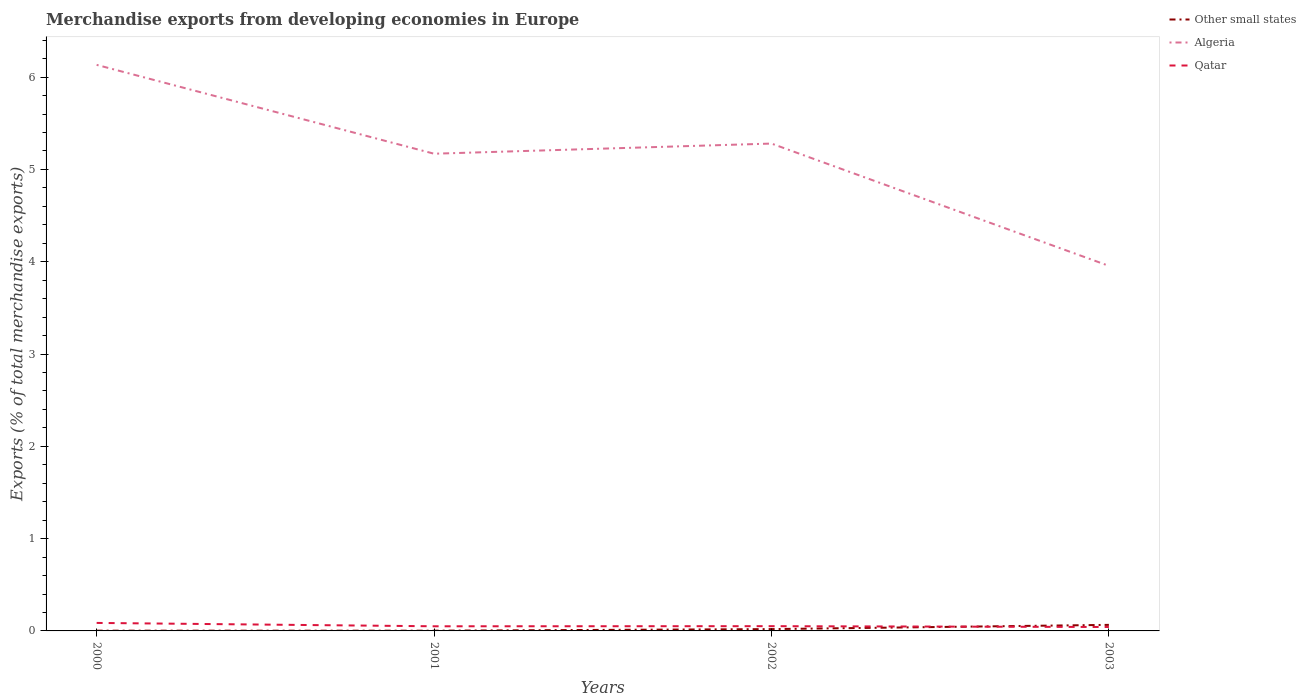Across all years, what is the maximum percentage of total merchandise exports in Algeria?
Offer a very short reply. 3.96. In which year was the percentage of total merchandise exports in Qatar maximum?
Offer a terse response. 2003. What is the total percentage of total merchandise exports in Algeria in the graph?
Give a very brief answer. 0.85. What is the difference between the highest and the second highest percentage of total merchandise exports in Other small states?
Provide a short and direct response. 0.06. What is the difference between the highest and the lowest percentage of total merchandise exports in Other small states?
Your answer should be very brief. 1. How many lines are there?
Offer a terse response. 3. Are the values on the major ticks of Y-axis written in scientific E-notation?
Provide a short and direct response. No. Where does the legend appear in the graph?
Your answer should be very brief. Top right. How many legend labels are there?
Make the answer very short. 3. How are the legend labels stacked?
Offer a terse response. Vertical. What is the title of the graph?
Keep it short and to the point. Merchandise exports from developing economies in Europe. Does "Korea (Republic)" appear as one of the legend labels in the graph?
Make the answer very short. No. What is the label or title of the Y-axis?
Make the answer very short. Exports (% of total merchandise exports). What is the Exports (% of total merchandise exports) in Other small states in 2000?
Your answer should be very brief. 0. What is the Exports (% of total merchandise exports) in Algeria in 2000?
Offer a terse response. 6.13. What is the Exports (% of total merchandise exports) in Qatar in 2000?
Make the answer very short. 0.09. What is the Exports (% of total merchandise exports) in Other small states in 2001?
Give a very brief answer. 0. What is the Exports (% of total merchandise exports) in Algeria in 2001?
Make the answer very short. 5.17. What is the Exports (% of total merchandise exports) in Qatar in 2001?
Your response must be concise. 0.05. What is the Exports (% of total merchandise exports) in Other small states in 2002?
Offer a terse response. 0.02. What is the Exports (% of total merchandise exports) of Algeria in 2002?
Offer a very short reply. 5.28. What is the Exports (% of total merchandise exports) of Qatar in 2002?
Your response must be concise. 0.05. What is the Exports (% of total merchandise exports) in Other small states in 2003?
Your answer should be very brief. 0.07. What is the Exports (% of total merchandise exports) in Algeria in 2003?
Keep it short and to the point. 3.96. What is the Exports (% of total merchandise exports) of Qatar in 2003?
Make the answer very short. 0.04. Across all years, what is the maximum Exports (% of total merchandise exports) of Other small states?
Give a very brief answer. 0.07. Across all years, what is the maximum Exports (% of total merchandise exports) in Algeria?
Provide a short and direct response. 6.13. Across all years, what is the maximum Exports (% of total merchandise exports) of Qatar?
Offer a terse response. 0.09. Across all years, what is the minimum Exports (% of total merchandise exports) of Other small states?
Your answer should be compact. 0. Across all years, what is the minimum Exports (% of total merchandise exports) of Algeria?
Offer a terse response. 3.96. Across all years, what is the minimum Exports (% of total merchandise exports) in Qatar?
Offer a very short reply. 0.04. What is the total Exports (% of total merchandise exports) of Other small states in the graph?
Provide a succinct answer. 0.09. What is the total Exports (% of total merchandise exports) in Algeria in the graph?
Offer a terse response. 20.54. What is the total Exports (% of total merchandise exports) in Qatar in the graph?
Your answer should be compact. 0.23. What is the difference between the Exports (% of total merchandise exports) of Other small states in 2000 and that in 2001?
Give a very brief answer. 0. What is the difference between the Exports (% of total merchandise exports) of Algeria in 2000 and that in 2001?
Keep it short and to the point. 0.96. What is the difference between the Exports (% of total merchandise exports) of Qatar in 2000 and that in 2001?
Your response must be concise. 0.04. What is the difference between the Exports (% of total merchandise exports) in Other small states in 2000 and that in 2002?
Your answer should be very brief. -0.02. What is the difference between the Exports (% of total merchandise exports) of Algeria in 2000 and that in 2002?
Give a very brief answer. 0.85. What is the difference between the Exports (% of total merchandise exports) in Qatar in 2000 and that in 2002?
Your response must be concise. 0.04. What is the difference between the Exports (% of total merchandise exports) in Other small states in 2000 and that in 2003?
Provide a succinct answer. -0.06. What is the difference between the Exports (% of total merchandise exports) in Algeria in 2000 and that in 2003?
Make the answer very short. 2.18. What is the difference between the Exports (% of total merchandise exports) of Qatar in 2000 and that in 2003?
Ensure brevity in your answer.  0.04. What is the difference between the Exports (% of total merchandise exports) of Other small states in 2001 and that in 2002?
Offer a very short reply. -0.02. What is the difference between the Exports (% of total merchandise exports) of Algeria in 2001 and that in 2002?
Provide a short and direct response. -0.11. What is the difference between the Exports (% of total merchandise exports) in Qatar in 2001 and that in 2002?
Offer a terse response. -0. What is the difference between the Exports (% of total merchandise exports) in Other small states in 2001 and that in 2003?
Offer a terse response. -0.06. What is the difference between the Exports (% of total merchandise exports) in Algeria in 2001 and that in 2003?
Offer a very short reply. 1.22. What is the difference between the Exports (% of total merchandise exports) of Qatar in 2001 and that in 2003?
Provide a short and direct response. 0.01. What is the difference between the Exports (% of total merchandise exports) of Other small states in 2002 and that in 2003?
Provide a short and direct response. -0.05. What is the difference between the Exports (% of total merchandise exports) in Algeria in 2002 and that in 2003?
Provide a succinct answer. 1.32. What is the difference between the Exports (% of total merchandise exports) of Qatar in 2002 and that in 2003?
Keep it short and to the point. 0.01. What is the difference between the Exports (% of total merchandise exports) of Other small states in 2000 and the Exports (% of total merchandise exports) of Algeria in 2001?
Offer a terse response. -5.17. What is the difference between the Exports (% of total merchandise exports) of Other small states in 2000 and the Exports (% of total merchandise exports) of Qatar in 2001?
Your answer should be compact. -0.05. What is the difference between the Exports (% of total merchandise exports) of Algeria in 2000 and the Exports (% of total merchandise exports) of Qatar in 2001?
Ensure brevity in your answer.  6.08. What is the difference between the Exports (% of total merchandise exports) of Other small states in 2000 and the Exports (% of total merchandise exports) of Algeria in 2002?
Your response must be concise. -5.28. What is the difference between the Exports (% of total merchandise exports) in Other small states in 2000 and the Exports (% of total merchandise exports) in Qatar in 2002?
Provide a succinct answer. -0.05. What is the difference between the Exports (% of total merchandise exports) in Algeria in 2000 and the Exports (% of total merchandise exports) in Qatar in 2002?
Offer a very short reply. 6.08. What is the difference between the Exports (% of total merchandise exports) of Other small states in 2000 and the Exports (% of total merchandise exports) of Algeria in 2003?
Keep it short and to the point. -3.95. What is the difference between the Exports (% of total merchandise exports) of Other small states in 2000 and the Exports (% of total merchandise exports) of Qatar in 2003?
Your answer should be very brief. -0.04. What is the difference between the Exports (% of total merchandise exports) in Algeria in 2000 and the Exports (% of total merchandise exports) in Qatar in 2003?
Give a very brief answer. 6.09. What is the difference between the Exports (% of total merchandise exports) of Other small states in 2001 and the Exports (% of total merchandise exports) of Algeria in 2002?
Your answer should be compact. -5.28. What is the difference between the Exports (% of total merchandise exports) in Other small states in 2001 and the Exports (% of total merchandise exports) in Qatar in 2002?
Your response must be concise. -0.05. What is the difference between the Exports (% of total merchandise exports) of Algeria in 2001 and the Exports (% of total merchandise exports) of Qatar in 2002?
Your answer should be very brief. 5.12. What is the difference between the Exports (% of total merchandise exports) of Other small states in 2001 and the Exports (% of total merchandise exports) of Algeria in 2003?
Provide a short and direct response. -3.95. What is the difference between the Exports (% of total merchandise exports) of Other small states in 2001 and the Exports (% of total merchandise exports) of Qatar in 2003?
Give a very brief answer. -0.04. What is the difference between the Exports (% of total merchandise exports) of Algeria in 2001 and the Exports (% of total merchandise exports) of Qatar in 2003?
Your answer should be compact. 5.13. What is the difference between the Exports (% of total merchandise exports) in Other small states in 2002 and the Exports (% of total merchandise exports) in Algeria in 2003?
Ensure brevity in your answer.  -3.94. What is the difference between the Exports (% of total merchandise exports) in Other small states in 2002 and the Exports (% of total merchandise exports) in Qatar in 2003?
Ensure brevity in your answer.  -0.02. What is the difference between the Exports (% of total merchandise exports) of Algeria in 2002 and the Exports (% of total merchandise exports) of Qatar in 2003?
Provide a short and direct response. 5.24. What is the average Exports (% of total merchandise exports) of Other small states per year?
Your answer should be compact. 0.02. What is the average Exports (% of total merchandise exports) of Algeria per year?
Your answer should be compact. 5.13. What is the average Exports (% of total merchandise exports) of Qatar per year?
Offer a terse response. 0.06. In the year 2000, what is the difference between the Exports (% of total merchandise exports) of Other small states and Exports (% of total merchandise exports) of Algeria?
Provide a succinct answer. -6.13. In the year 2000, what is the difference between the Exports (% of total merchandise exports) in Other small states and Exports (% of total merchandise exports) in Qatar?
Ensure brevity in your answer.  -0.08. In the year 2000, what is the difference between the Exports (% of total merchandise exports) in Algeria and Exports (% of total merchandise exports) in Qatar?
Your answer should be very brief. 6.05. In the year 2001, what is the difference between the Exports (% of total merchandise exports) in Other small states and Exports (% of total merchandise exports) in Algeria?
Keep it short and to the point. -5.17. In the year 2001, what is the difference between the Exports (% of total merchandise exports) in Other small states and Exports (% of total merchandise exports) in Qatar?
Ensure brevity in your answer.  -0.05. In the year 2001, what is the difference between the Exports (% of total merchandise exports) in Algeria and Exports (% of total merchandise exports) in Qatar?
Give a very brief answer. 5.12. In the year 2002, what is the difference between the Exports (% of total merchandise exports) of Other small states and Exports (% of total merchandise exports) of Algeria?
Make the answer very short. -5.26. In the year 2002, what is the difference between the Exports (% of total merchandise exports) in Other small states and Exports (% of total merchandise exports) in Qatar?
Make the answer very short. -0.03. In the year 2002, what is the difference between the Exports (% of total merchandise exports) in Algeria and Exports (% of total merchandise exports) in Qatar?
Your response must be concise. 5.23. In the year 2003, what is the difference between the Exports (% of total merchandise exports) of Other small states and Exports (% of total merchandise exports) of Algeria?
Your response must be concise. -3.89. In the year 2003, what is the difference between the Exports (% of total merchandise exports) in Other small states and Exports (% of total merchandise exports) in Qatar?
Ensure brevity in your answer.  0.02. In the year 2003, what is the difference between the Exports (% of total merchandise exports) in Algeria and Exports (% of total merchandise exports) in Qatar?
Give a very brief answer. 3.91. What is the ratio of the Exports (% of total merchandise exports) of Other small states in 2000 to that in 2001?
Your answer should be very brief. 1.13. What is the ratio of the Exports (% of total merchandise exports) of Algeria in 2000 to that in 2001?
Make the answer very short. 1.19. What is the ratio of the Exports (% of total merchandise exports) of Qatar in 2000 to that in 2001?
Provide a succinct answer. 1.73. What is the ratio of the Exports (% of total merchandise exports) of Other small states in 2000 to that in 2002?
Make the answer very short. 0.14. What is the ratio of the Exports (% of total merchandise exports) in Algeria in 2000 to that in 2002?
Your response must be concise. 1.16. What is the ratio of the Exports (% of total merchandise exports) in Qatar in 2000 to that in 2002?
Offer a terse response. 1.68. What is the ratio of the Exports (% of total merchandise exports) in Other small states in 2000 to that in 2003?
Keep it short and to the point. 0.04. What is the ratio of the Exports (% of total merchandise exports) in Algeria in 2000 to that in 2003?
Your response must be concise. 1.55. What is the ratio of the Exports (% of total merchandise exports) of Qatar in 2000 to that in 2003?
Your response must be concise. 2.04. What is the ratio of the Exports (% of total merchandise exports) of Other small states in 2001 to that in 2002?
Provide a short and direct response. 0.12. What is the ratio of the Exports (% of total merchandise exports) in Algeria in 2001 to that in 2002?
Ensure brevity in your answer.  0.98. What is the ratio of the Exports (% of total merchandise exports) in Qatar in 2001 to that in 2002?
Offer a terse response. 0.98. What is the ratio of the Exports (% of total merchandise exports) in Other small states in 2001 to that in 2003?
Offer a very short reply. 0.04. What is the ratio of the Exports (% of total merchandise exports) in Algeria in 2001 to that in 2003?
Your response must be concise. 1.31. What is the ratio of the Exports (% of total merchandise exports) of Qatar in 2001 to that in 2003?
Your answer should be very brief. 1.18. What is the ratio of the Exports (% of total merchandise exports) of Other small states in 2002 to that in 2003?
Your answer should be very brief. 0.3. What is the ratio of the Exports (% of total merchandise exports) of Algeria in 2002 to that in 2003?
Give a very brief answer. 1.33. What is the ratio of the Exports (% of total merchandise exports) in Qatar in 2002 to that in 2003?
Make the answer very short. 1.21. What is the difference between the highest and the second highest Exports (% of total merchandise exports) in Other small states?
Provide a succinct answer. 0.05. What is the difference between the highest and the second highest Exports (% of total merchandise exports) of Algeria?
Offer a very short reply. 0.85. What is the difference between the highest and the second highest Exports (% of total merchandise exports) in Qatar?
Provide a short and direct response. 0.04. What is the difference between the highest and the lowest Exports (% of total merchandise exports) of Other small states?
Offer a terse response. 0.06. What is the difference between the highest and the lowest Exports (% of total merchandise exports) in Algeria?
Ensure brevity in your answer.  2.18. What is the difference between the highest and the lowest Exports (% of total merchandise exports) in Qatar?
Ensure brevity in your answer.  0.04. 